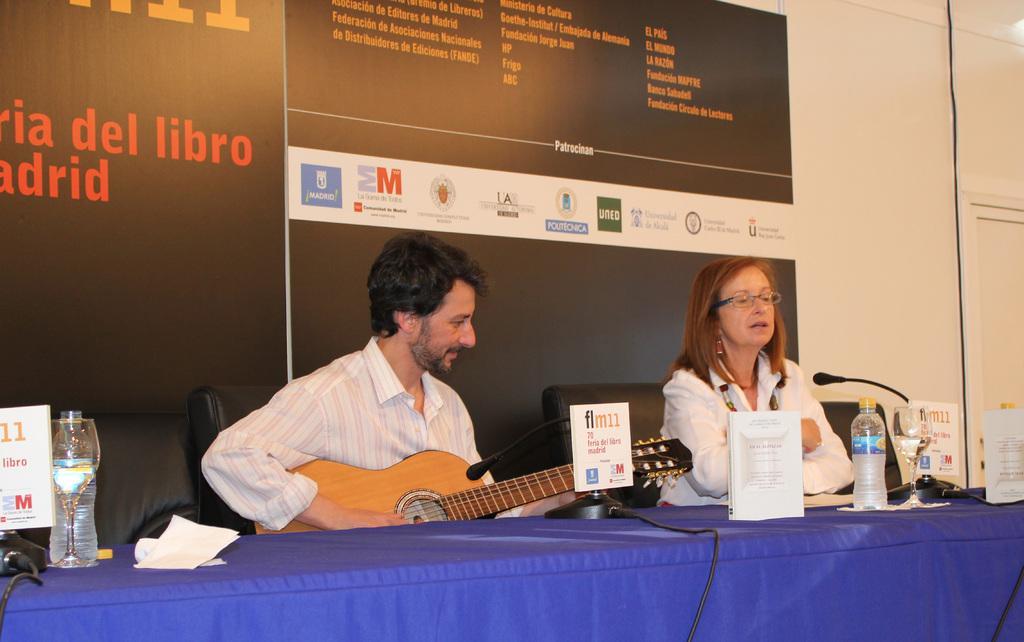Please provide a concise description of this image. In this picture there is a man and woman sitting and there is a table in front of them with some water bottles 